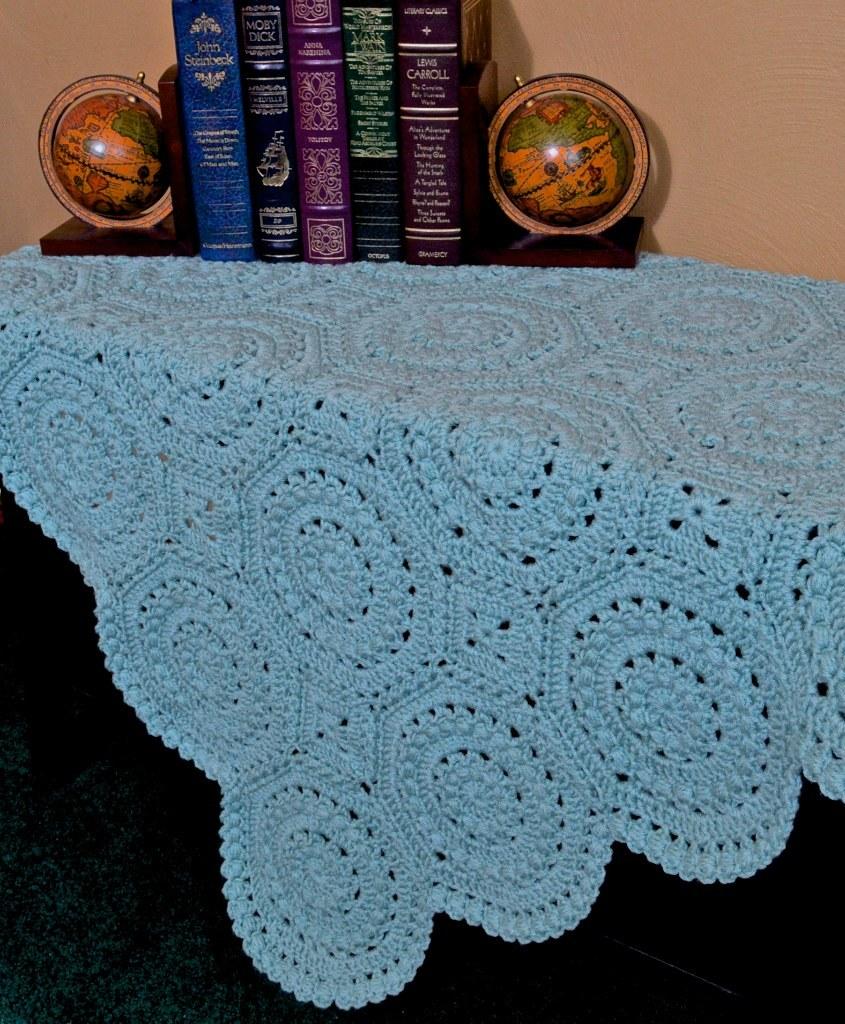What's the title of the black book?
Your answer should be compact. Moby dick. Who is the author of the blue book on the left?
Give a very brief answer. John steinbeck. 